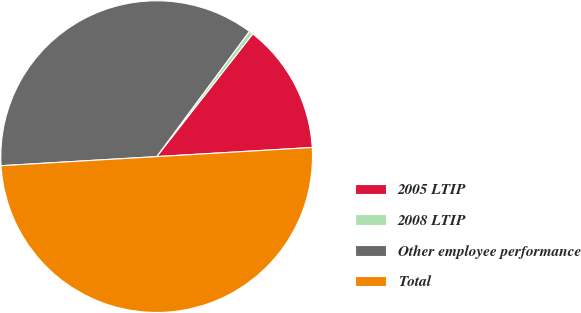Convert chart. <chart><loc_0><loc_0><loc_500><loc_500><pie_chart><fcel>2005 LTIP<fcel>2008 LTIP<fcel>Other employee performance<fcel>Total<nl><fcel>13.49%<fcel>0.43%<fcel>36.07%<fcel>50.0%<nl></chart> 